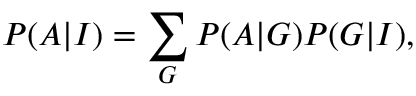Convert formula to latex. <formula><loc_0><loc_0><loc_500><loc_500>P ( A | I ) = \sum _ { G } P ( A | G ) P ( G | I ) ,</formula> 